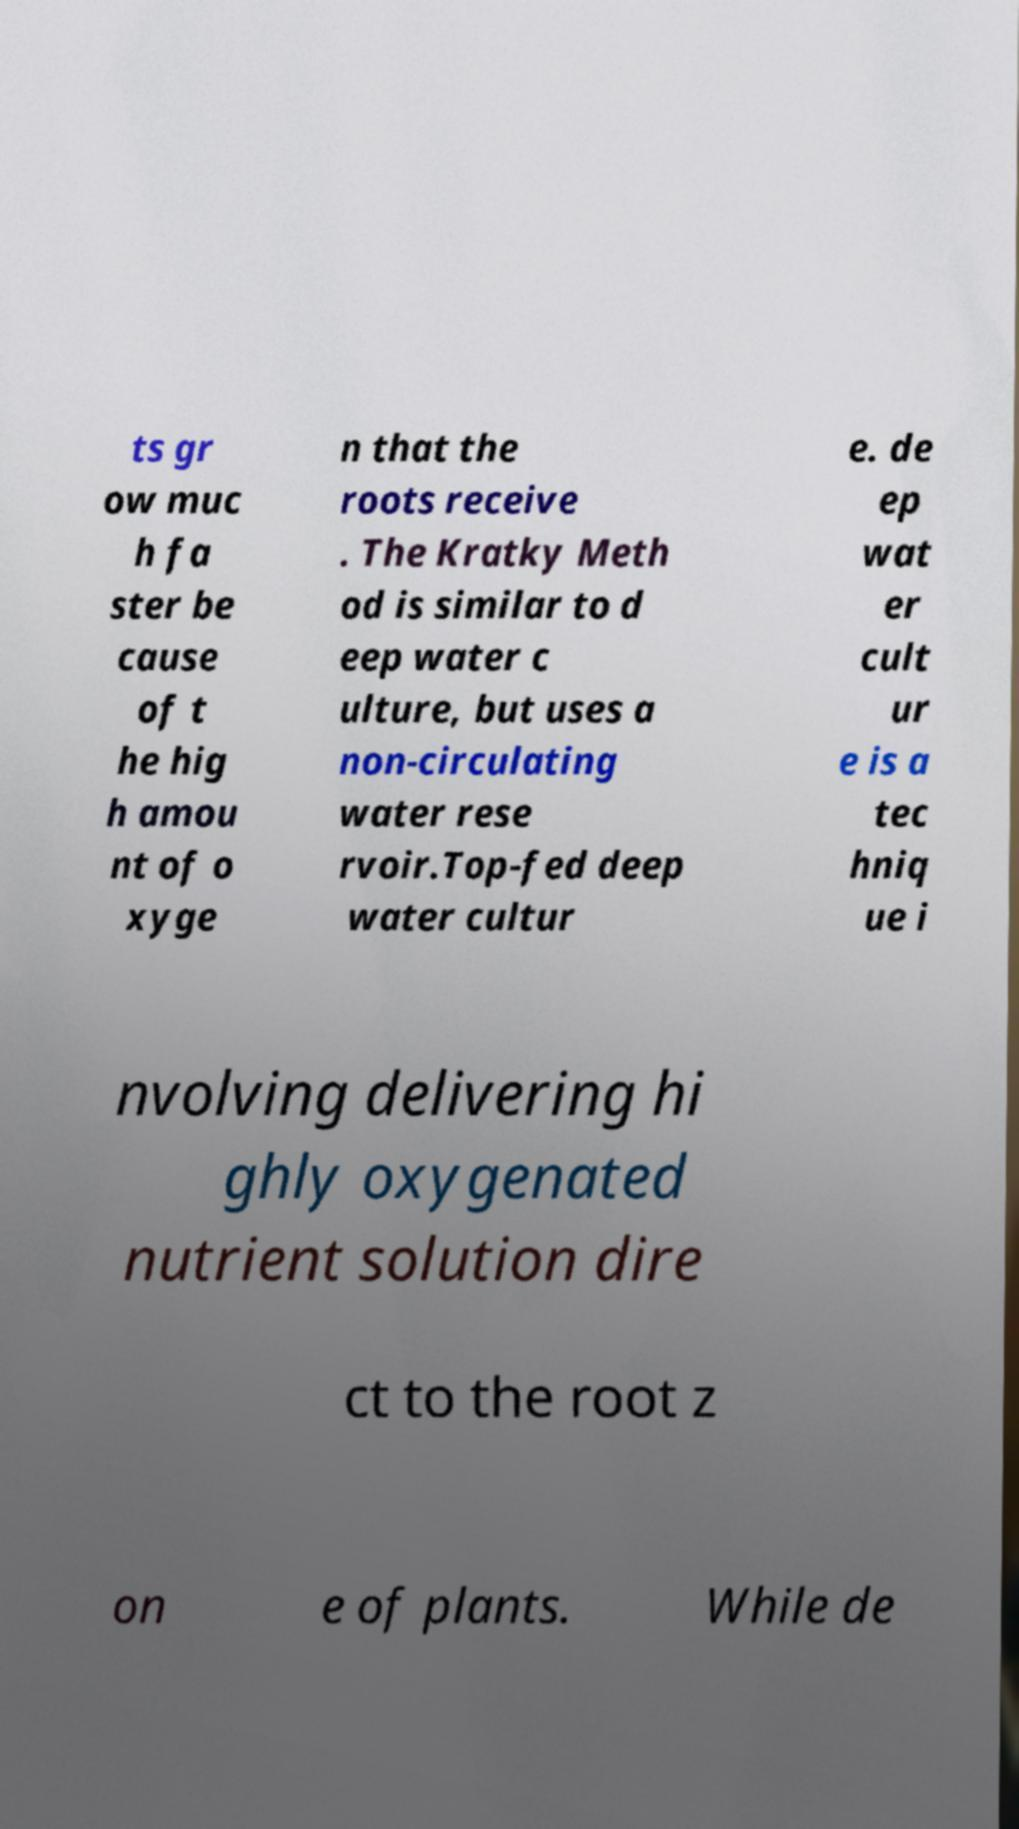Could you extract and type out the text from this image? ts gr ow muc h fa ster be cause of t he hig h amou nt of o xyge n that the roots receive . The Kratky Meth od is similar to d eep water c ulture, but uses a non-circulating water rese rvoir.Top-fed deep water cultur e. de ep wat er cult ur e is a tec hniq ue i nvolving delivering hi ghly oxygenated nutrient solution dire ct to the root z on e of plants. While de 